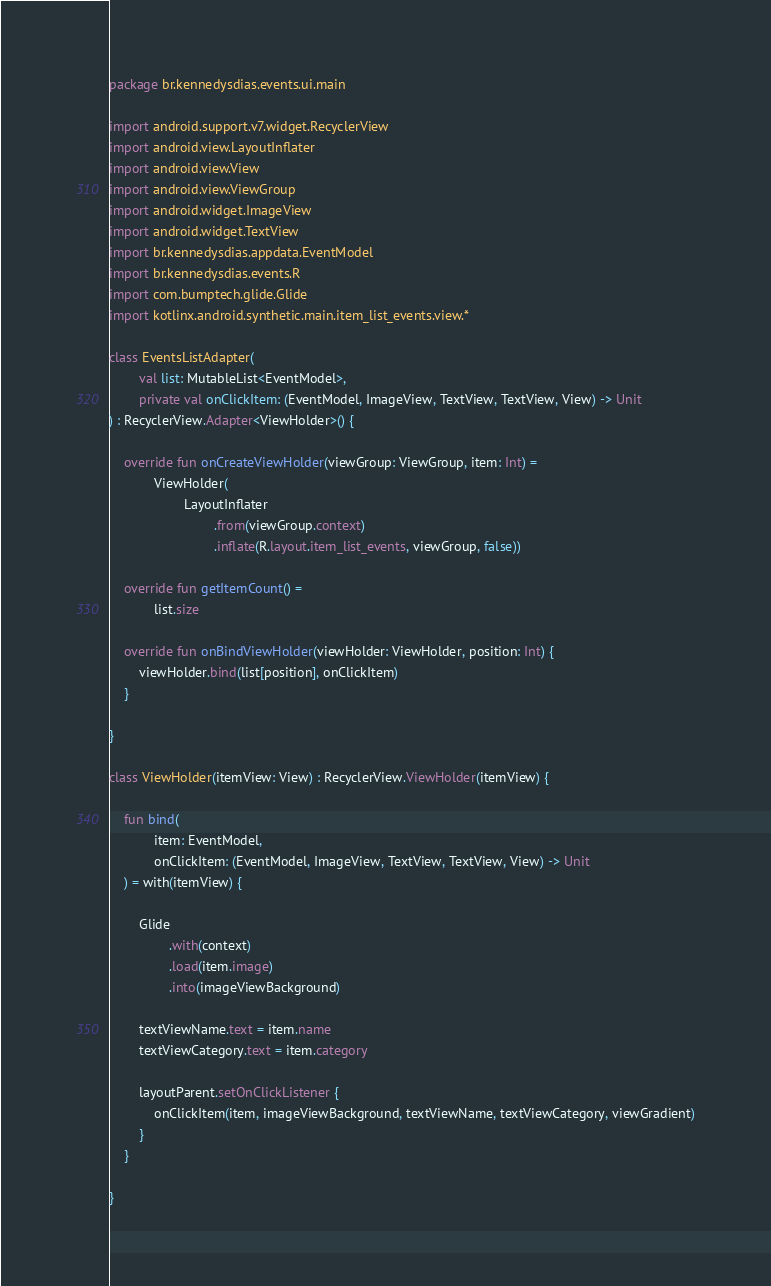Convert code to text. <code><loc_0><loc_0><loc_500><loc_500><_Kotlin_>package br.kennedysdias.events.ui.main

import android.support.v7.widget.RecyclerView
import android.view.LayoutInflater
import android.view.View
import android.view.ViewGroup
import android.widget.ImageView
import android.widget.TextView
import br.kennedysdias.appdata.EventModel
import br.kennedysdias.events.R
import com.bumptech.glide.Glide
import kotlinx.android.synthetic.main.item_list_events.view.*

class EventsListAdapter(
		val list: MutableList<EventModel>,
		private val onClickItem: (EventModel, ImageView, TextView, TextView, View) -> Unit
) : RecyclerView.Adapter<ViewHolder>() {

	override fun onCreateViewHolder(viewGroup: ViewGroup, item: Int) =
			ViewHolder(
					LayoutInflater
							.from(viewGroup.context)
							.inflate(R.layout.item_list_events, viewGroup, false))

	override fun getItemCount() =
			list.size

	override fun onBindViewHolder(viewHolder: ViewHolder, position: Int) {
		viewHolder.bind(list[position], onClickItem)
	}

}

class ViewHolder(itemView: View) : RecyclerView.ViewHolder(itemView) {

	fun bind(
			item: EventModel,
			onClickItem: (EventModel, ImageView, TextView, TextView, View) -> Unit
	) = with(itemView) {

		Glide
				.with(context)
				.load(item.image)
				.into(imageViewBackground)

		textViewName.text = item.name
		textViewCategory.text = item.category

		layoutParent.setOnClickListener {
			onClickItem(item, imageViewBackground, textViewName, textViewCategory, viewGradient)
		}
	}

}</code> 